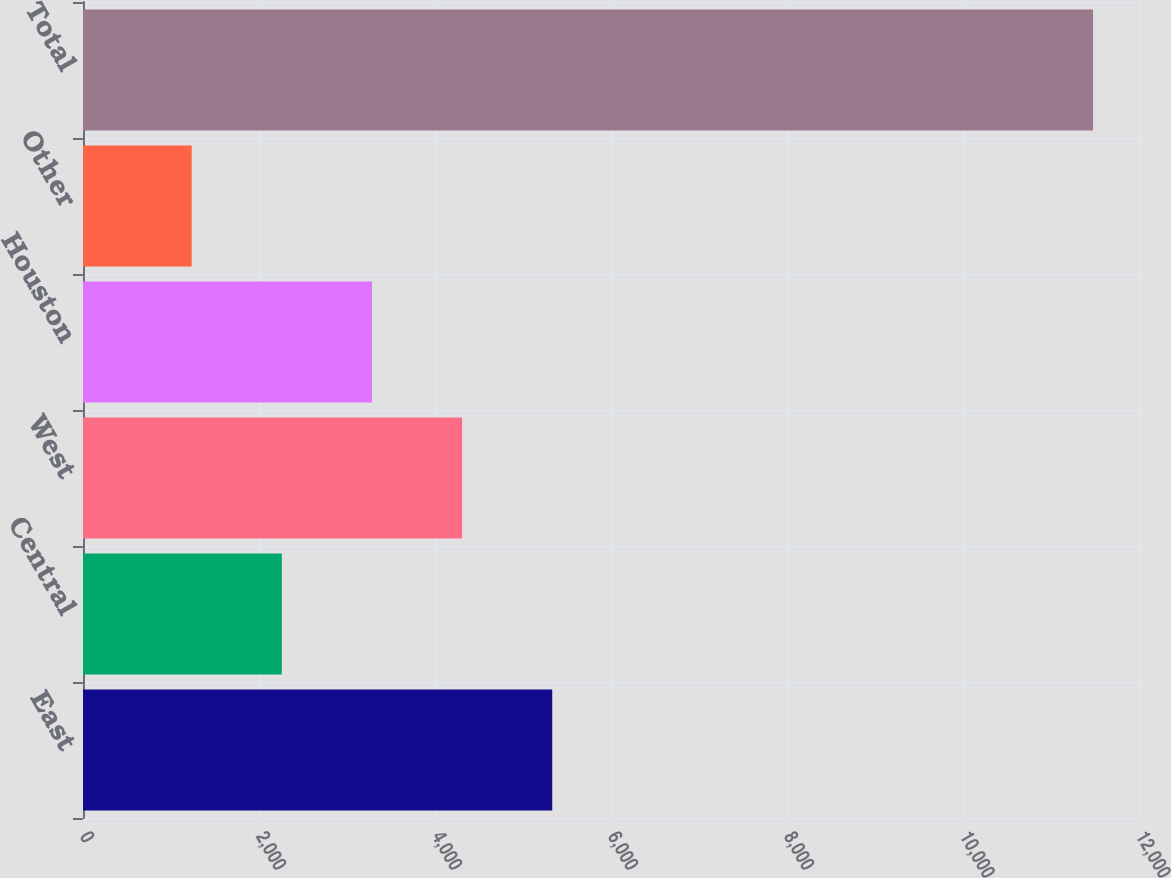<chart> <loc_0><loc_0><loc_500><loc_500><bar_chart><fcel>East<fcel>Central<fcel>West<fcel>Houston<fcel>Other<fcel>Total<nl><fcel>5332.2<fcel>2259.3<fcel>4307.9<fcel>3283.6<fcel>1235<fcel>11478<nl></chart> 